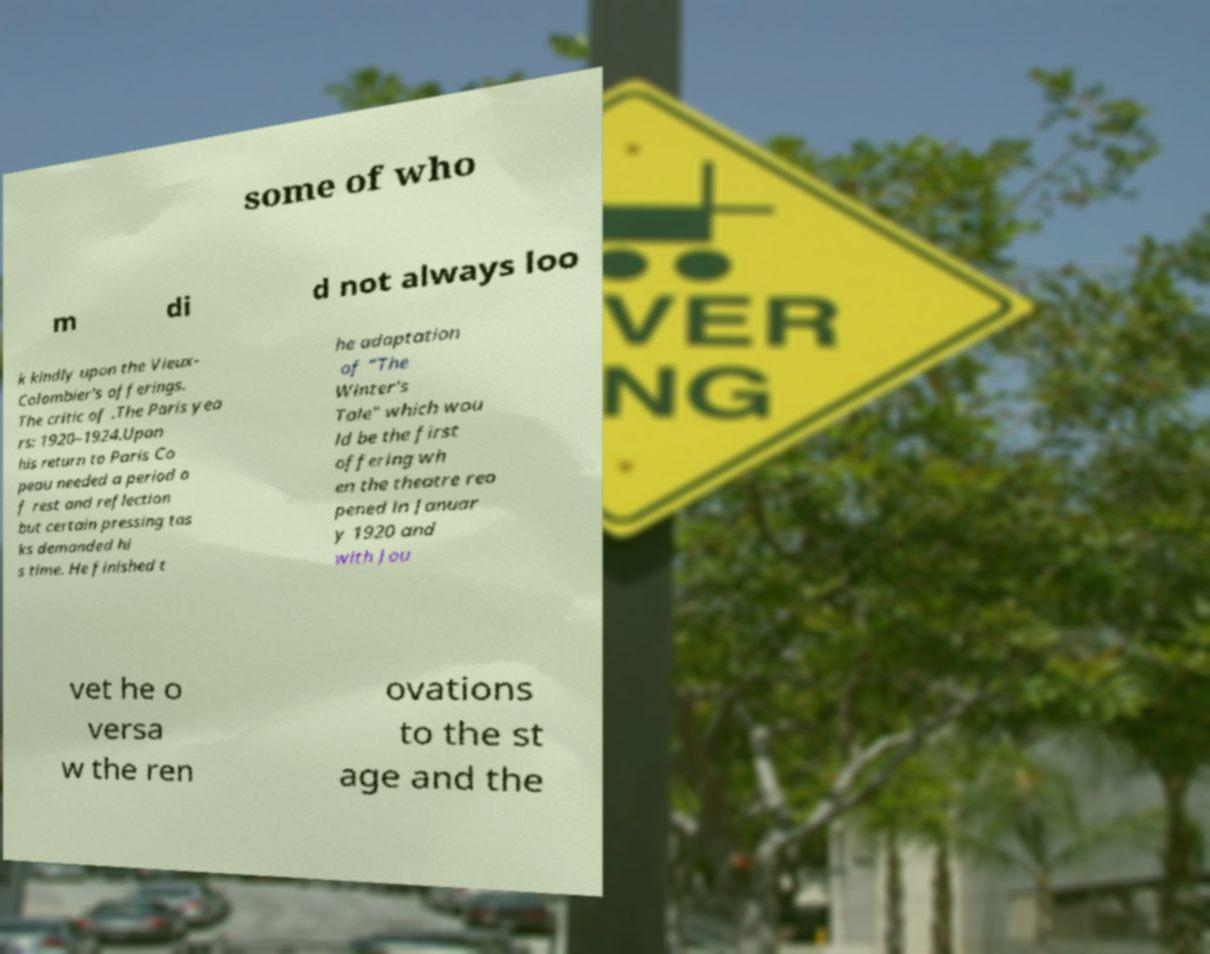Please identify and transcribe the text found in this image. some of who m di d not always loo k kindly upon the Vieux- Colombier's offerings. The critic of .The Paris yea rs: 1920–1924.Upon his return to Paris Co peau needed a period o f rest and reflection but certain pressing tas ks demanded hi s time. He finished t he adaptation of "The Winter's Tale" which wou ld be the first offering wh en the theatre reo pened in Januar y 1920 and with Jou vet he o versa w the ren ovations to the st age and the 